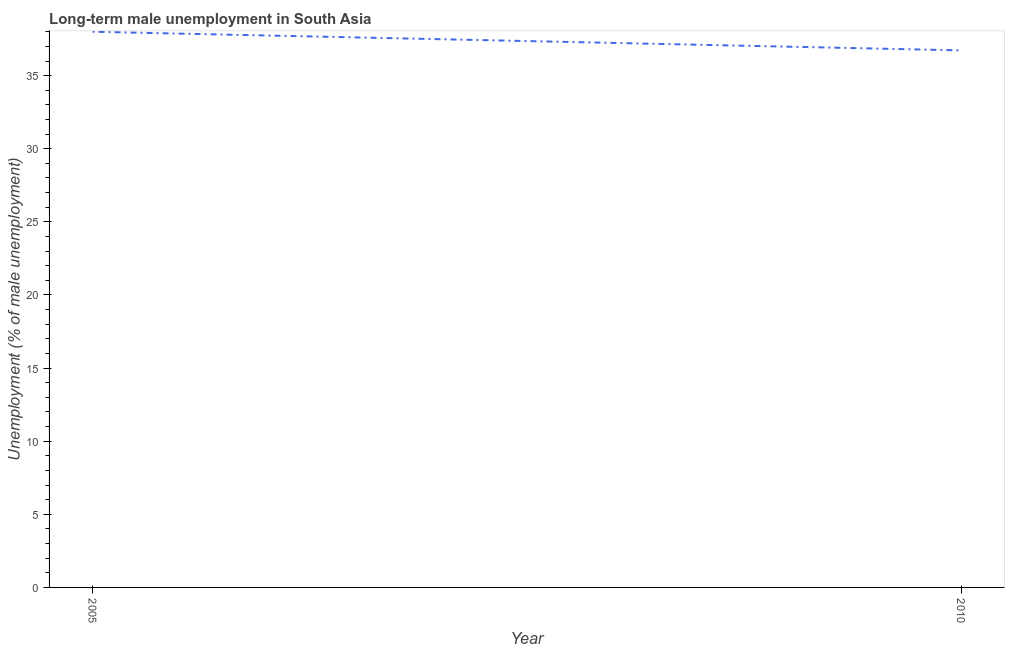Across all years, what is the maximum long-term male unemployment?
Ensure brevity in your answer.  38. Across all years, what is the minimum long-term male unemployment?
Your answer should be very brief. 36.73. In which year was the long-term male unemployment maximum?
Provide a short and direct response. 2005. In which year was the long-term male unemployment minimum?
Provide a succinct answer. 2010. What is the sum of the long-term male unemployment?
Offer a terse response. 74.73. What is the difference between the long-term male unemployment in 2005 and 2010?
Offer a terse response. 1.27. What is the average long-term male unemployment per year?
Make the answer very short. 37.36. What is the median long-term male unemployment?
Ensure brevity in your answer.  37.36. What is the ratio of the long-term male unemployment in 2005 to that in 2010?
Your answer should be compact. 1.03. Is the long-term male unemployment in 2005 less than that in 2010?
Keep it short and to the point. No. In how many years, is the long-term male unemployment greater than the average long-term male unemployment taken over all years?
Offer a terse response. 1. How many lines are there?
Offer a very short reply. 1. Does the graph contain any zero values?
Ensure brevity in your answer.  No. What is the title of the graph?
Make the answer very short. Long-term male unemployment in South Asia. What is the label or title of the Y-axis?
Make the answer very short. Unemployment (% of male unemployment). What is the Unemployment (% of male unemployment) in 2005?
Offer a very short reply. 38. What is the Unemployment (% of male unemployment) in 2010?
Provide a succinct answer. 36.73. What is the difference between the Unemployment (% of male unemployment) in 2005 and 2010?
Give a very brief answer. 1.27. What is the ratio of the Unemployment (% of male unemployment) in 2005 to that in 2010?
Ensure brevity in your answer.  1.03. 